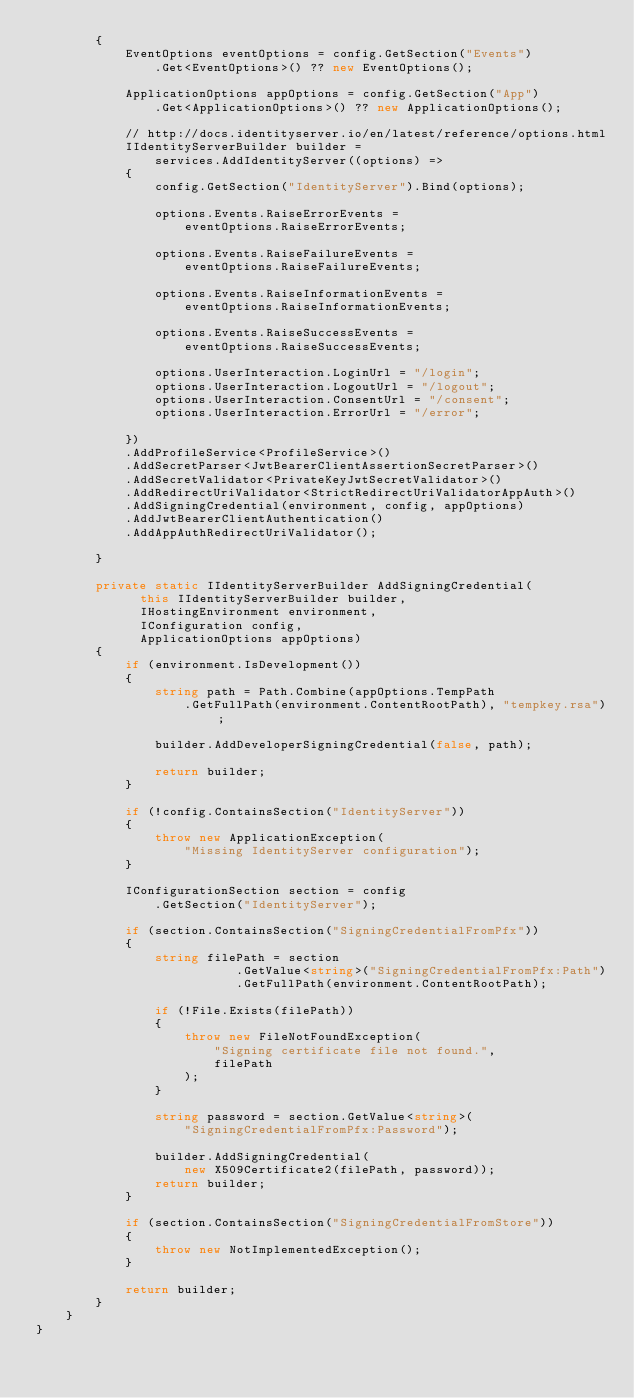Convert code to text. <code><loc_0><loc_0><loc_500><loc_500><_C#_>        {
            EventOptions eventOptions = config.GetSection("Events")
                .Get<EventOptions>() ?? new EventOptions();

            ApplicationOptions appOptions = config.GetSection("App")
                .Get<ApplicationOptions>() ?? new ApplicationOptions();

            // http://docs.identityserver.io/en/latest/reference/options.html
            IIdentityServerBuilder builder =
                services.AddIdentityServer((options) =>
            {
                config.GetSection("IdentityServer").Bind(options);

                options.Events.RaiseErrorEvents =
                    eventOptions.RaiseErrorEvents;

                options.Events.RaiseFailureEvents =
                    eventOptions.RaiseFailureEvents;

                options.Events.RaiseInformationEvents =
                    eventOptions.RaiseInformationEvents;

                options.Events.RaiseSuccessEvents =
                    eventOptions.RaiseSuccessEvents;

                options.UserInteraction.LoginUrl = "/login";
                options.UserInteraction.LogoutUrl = "/logout";
                options.UserInteraction.ConsentUrl = "/consent";
                options.UserInteraction.ErrorUrl = "/error";

            })
            .AddProfileService<ProfileService>()
            .AddSecretParser<JwtBearerClientAssertionSecretParser>()
            .AddSecretValidator<PrivateKeyJwtSecretValidator>()
            .AddRedirectUriValidator<StrictRedirectUriValidatorAppAuth>()
            .AddSigningCredential(environment, config, appOptions)
            .AddJwtBearerClientAuthentication()
            .AddAppAuthRedirectUriValidator();

        }

        private static IIdentityServerBuilder AddSigningCredential(
              this IIdentityServerBuilder builder,
              IHostingEnvironment environment,
              IConfiguration config,
              ApplicationOptions appOptions)
        {
            if (environment.IsDevelopment())
            {
                string path = Path.Combine(appOptions.TempPath
                    .GetFullPath(environment.ContentRootPath), "tempkey.rsa");

                builder.AddDeveloperSigningCredential(false, path);

                return builder;
            }

            if (!config.ContainsSection("IdentityServer"))
            {
                throw new ApplicationException(
                    "Missing IdentityServer configuration");
            }

            IConfigurationSection section = config
                .GetSection("IdentityServer");

            if (section.ContainsSection("SigningCredentialFromPfx"))
            {
                string filePath = section
                           .GetValue<string>("SigningCredentialFromPfx:Path")
                           .GetFullPath(environment.ContentRootPath);

                if (!File.Exists(filePath))
                {
                    throw new FileNotFoundException(
                        "Signing certificate file not found.",
                        filePath
                    );
                }

                string password = section.GetValue<string>(
                    "SigningCredentialFromPfx:Password");

                builder.AddSigningCredential(
                    new X509Certificate2(filePath, password));
                return builder;
            }

            if (section.ContainsSection("SigningCredentialFromStore"))
            {
                throw new NotImplementedException();
            }

            return builder;
        }
    }
}</code> 